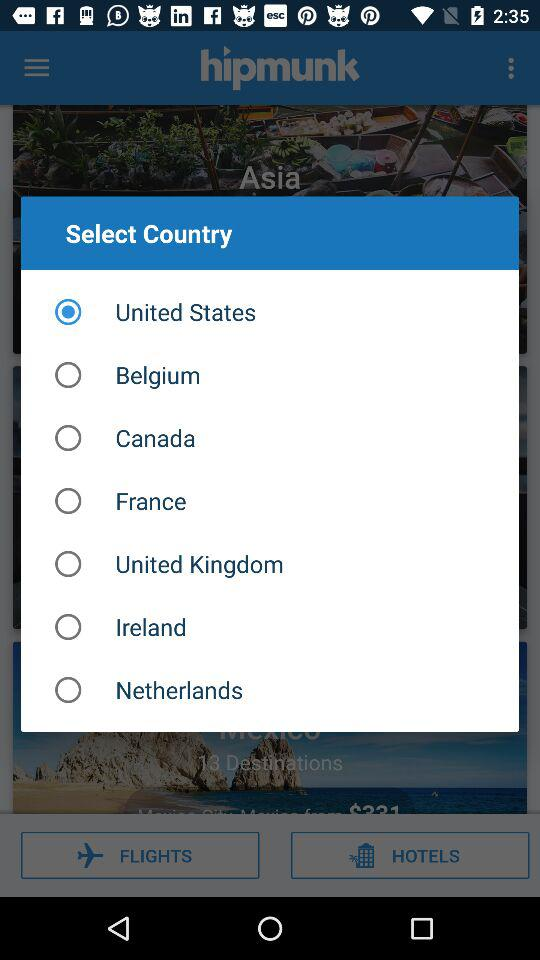What is the selected country? The selected country is the United States. 